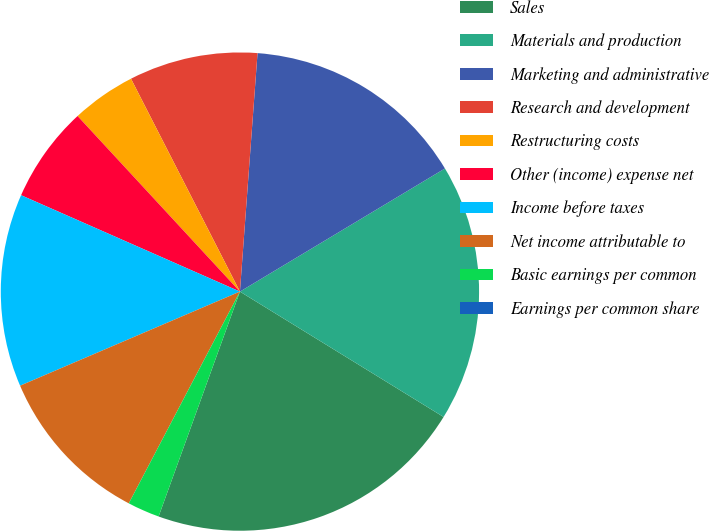Convert chart. <chart><loc_0><loc_0><loc_500><loc_500><pie_chart><fcel>Sales<fcel>Materials and production<fcel>Marketing and administrative<fcel>Research and development<fcel>Restructuring costs<fcel>Other (income) expense net<fcel>Income before taxes<fcel>Net income attributable to<fcel>Basic earnings per common<fcel>Earnings per common share<nl><fcel>21.74%<fcel>17.39%<fcel>15.22%<fcel>8.7%<fcel>4.35%<fcel>6.52%<fcel>13.04%<fcel>10.87%<fcel>2.17%<fcel>0.0%<nl></chart> 